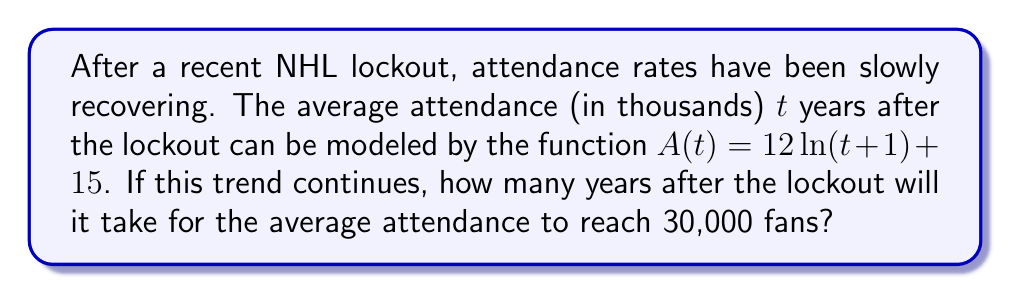Could you help me with this problem? Let's approach this step-by-step:

1) We need to solve the equation:
   $A(t) = 30$

2) Substituting the given function:
   $12 \ln(t+1) + 15 = 30$

3) Subtract 15 from both sides:
   $12 \ln(t+1) = 15$

4) Divide both sides by 12:
   $\ln(t+1) = \frac{5}{4}$

5) Apply the exponential function (e^) to both sides:
   $e^{\ln(t+1)} = e^{\frac{5}{4}}$

6) Simplify the left side:
   $t + 1 = e^{\frac{5}{4}}$

7) Subtract 1 from both sides:
   $t = e^{\frac{5}{4}} - 1$

8) Calculate the value:
   $t \approx 2.482$

9) Since we're dealing with years, we need to round up to the nearest whole year.
Answer: 3 years 